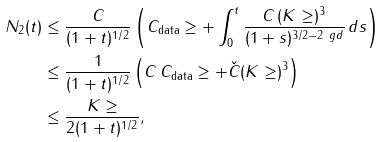<formula> <loc_0><loc_0><loc_500><loc_500>N _ { 2 } ( t ) & \leq \frac { C } { ( 1 + t ) ^ { 1 / 2 } } \left ( C _ { \text {data} } \geq + \int _ { 0 } ^ { t } \frac { C \, ( K \geq ) ^ { 3 } } { ( 1 + s ) ^ { 3 / 2 - 2 \ g d } } \, d s \right ) \\ & \leq \frac { 1 } { ( 1 + t ) ^ { 1 / 2 } } \left ( C \, C _ { \text {data} } \geq + \check { C } ( K \geq ) ^ { 3 } \right ) \\ & \leq \frac { K \geq } { 2 ( 1 + t ) ^ { 1 / 2 } } ,</formula> 